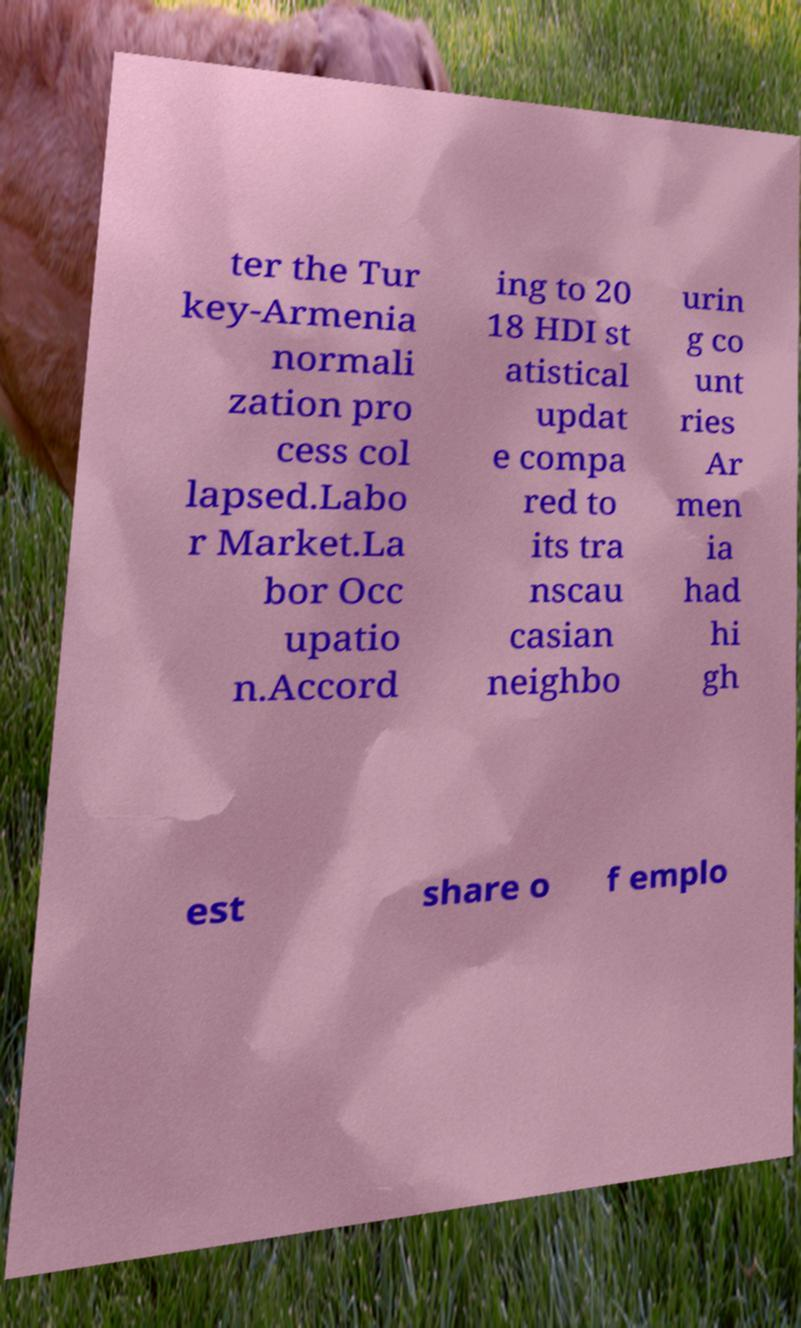Could you extract and type out the text from this image? ter the Tur key-Armenia normali zation pro cess col lapsed.Labo r Market.La bor Occ upatio n.Accord ing to 20 18 HDI st atistical updat e compa red to its tra nscau casian neighbo urin g co unt ries Ar men ia had hi gh est share o f emplo 